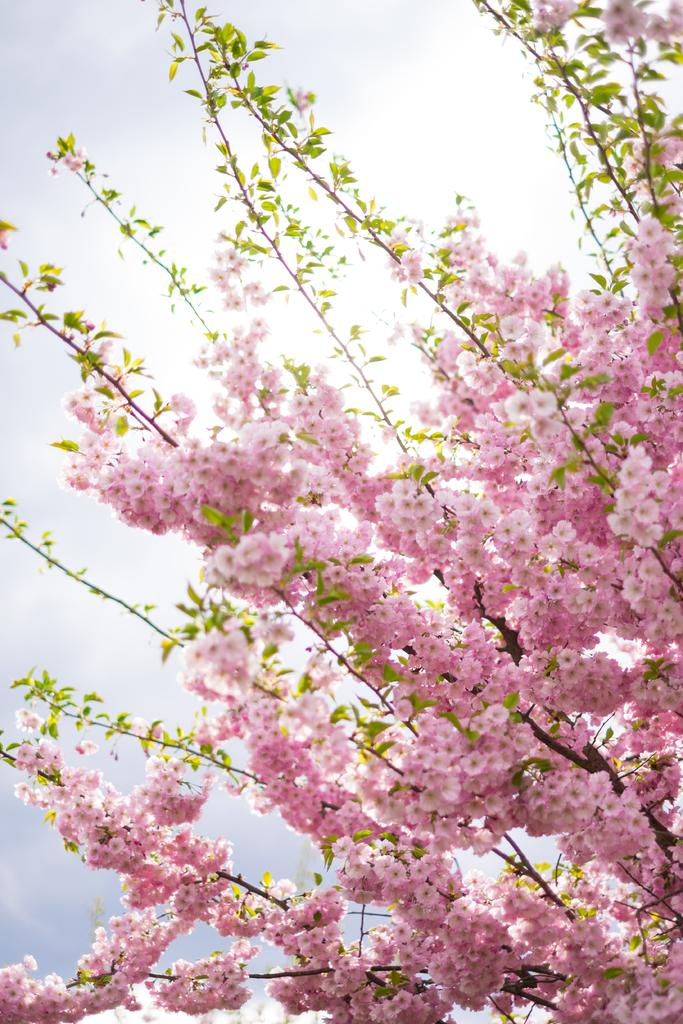What color are the flowers on the tree in the image? The flowers on the tree are pink. What is the condition of the sky in the image? The sky is cloudy. How many eggs are visible on the tree in the image? There are no eggs visible on the tree in the image. What type of material is the thing made of that is holding the flowers on the tree? There is no thing holding the flowers on the tree in the image, as the flowers are growing on the tree branches. 